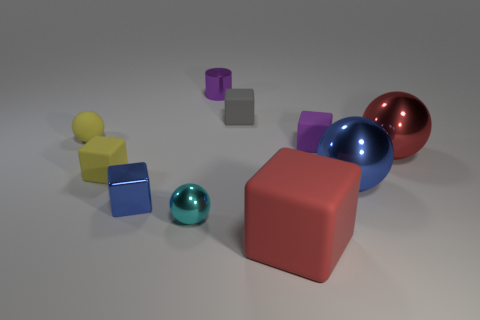Are there the same number of blocks on the left side of the purple matte thing and small blue metallic objects that are to the right of the tiny cyan metallic sphere?
Offer a terse response. No. Are the small ball that is in front of the red metallic thing and the gray thing made of the same material?
Your answer should be very brief. No. What is the color of the shiny object that is behind the small yellow block and to the right of the large red rubber object?
Offer a very short reply. Red. There is a big object in front of the tiny blue thing; how many small yellow things are right of it?
Keep it short and to the point. 0. What is the material of the gray object that is the same shape as the purple matte thing?
Keep it short and to the point. Rubber. The small cylinder is what color?
Ensure brevity in your answer.  Purple. What number of things are either small purple shiny things or big gray rubber spheres?
Ensure brevity in your answer.  1. The small object right of the big red object that is in front of the red sphere is what shape?
Provide a succinct answer. Cube. What number of other objects are there of the same material as the blue block?
Give a very brief answer. 4. Is the material of the tiny gray object the same as the tiny cylinder that is to the left of the large red ball?
Make the answer very short. No. 